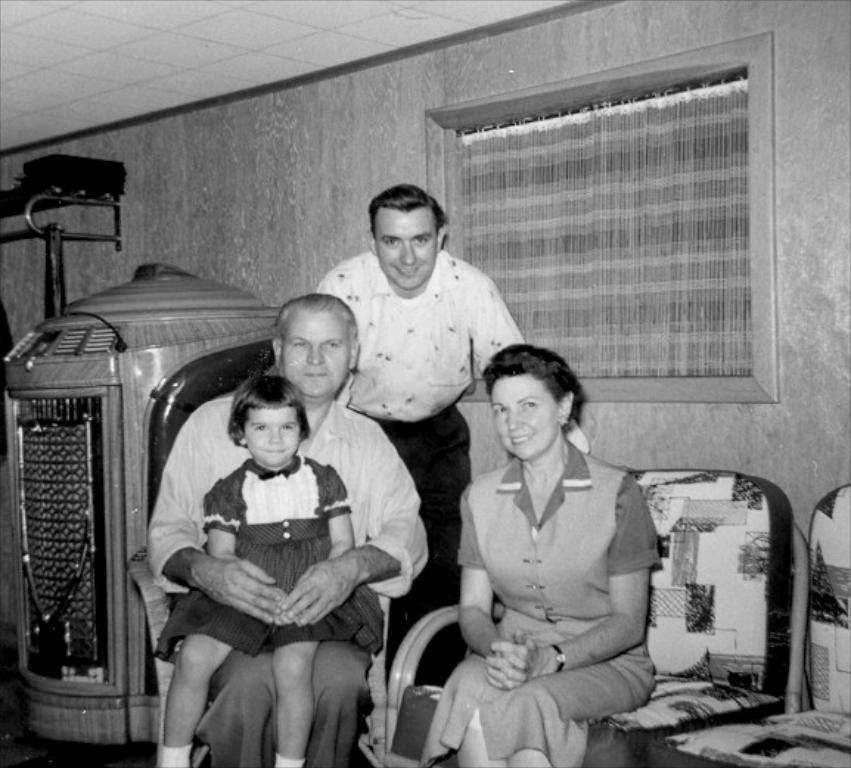Could you give a brief overview of what you see in this image? In this image we can see three people sitting, behind them there is a man standing and smiling. In the background there is a wall and a window. On the left we can see an object. On the right there are chairs. 